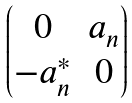<formula> <loc_0><loc_0><loc_500><loc_500>\begin{pmatrix} 0 & a _ { n } \\ - a _ { n } ^ { * } & 0 \end{pmatrix}</formula> 